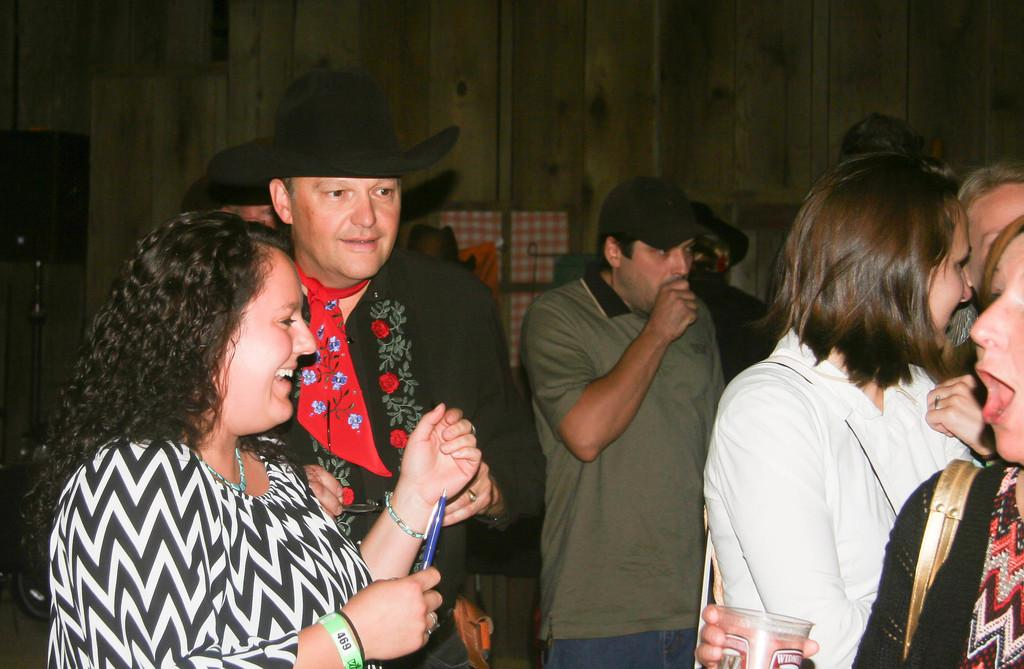What is the main subject of the image? The main subject of the image is a group of people. Can you describe the setting or environment in the image? There is a closed door in the background of the image. What type of haircut is the aunt giving to the person in the image? There is no aunt or haircut present in the image. Is there a rifle visible in the image? There is no rifle present in the image. 